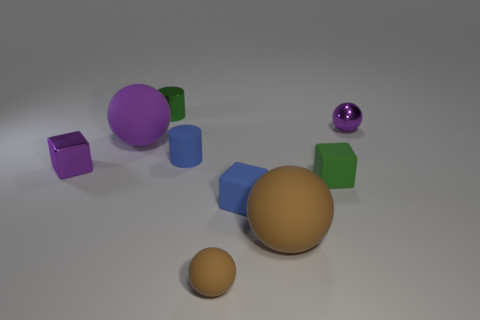There is a tiny object that is the same color as the metallic ball; what is it made of?
Give a very brief answer. Metal. What is the material of the small ball in front of the big brown thing?
Your answer should be very brief. Rubber. There is a green block that is the same size as the blue rubber cylinder; what is it made of?
Your answer should be compact. Rubber. The tiny green object in front of the purple shiny object that is left of the tiny green object behind the tiny purple metal cube is made of what material?
Offer a terse response. Rubber. Does the green thing that is left of the blue matte cylinder have the same size as the small purple cube?
Ensure brevity in your answer.  Yes. Is the number of blue matte cubes greater than the number of large objects?
Your answer should be very brief. No. How many large things are either shiny balls or red metal cubes?
Give a very brief answer. 0. What number of other things are the same color as the small metal cube?
Your response must be concise. 2. How many brown spheres have the same material as the large purple sphere?
Keep it short and to the point. 2. There is a big matte sphere right of the blue cube; is its color the same as the tiny matte sphere?
Your answer should be compact. Yes. 